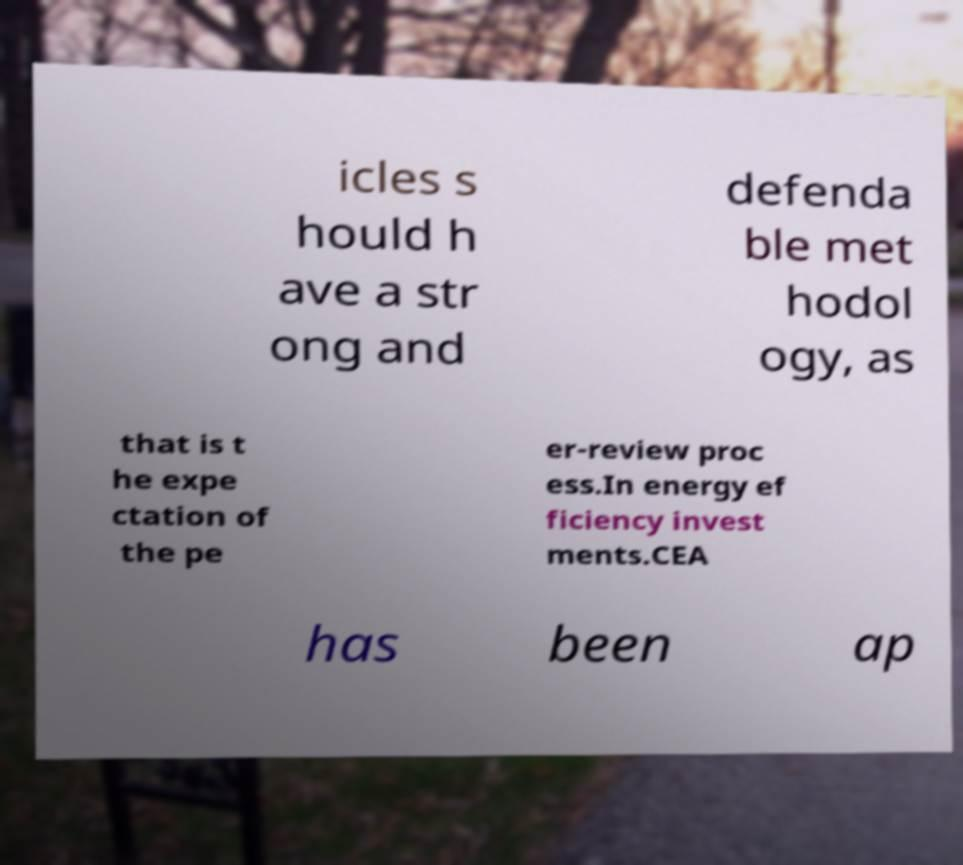For documentation purposes, I need the text within this image transcribed. Could you provide that? icles s hould h ave a str ong and defenda ble met hodol ogy, as that is t he expe ctation of the pe er-review proc ess.In energy ef ficiency invest ments.CEA has been ap 